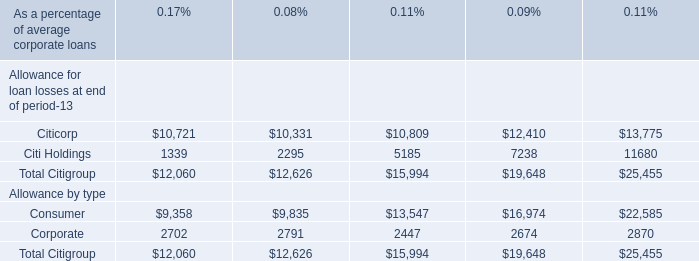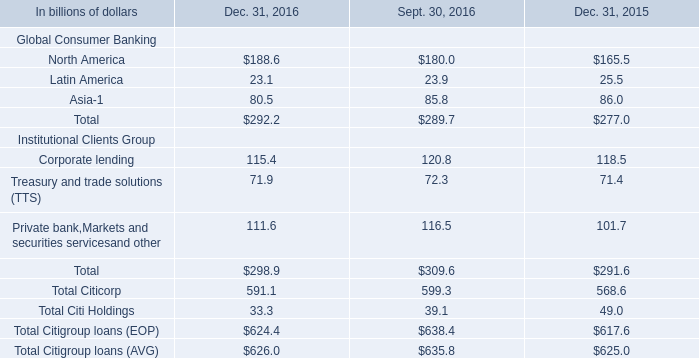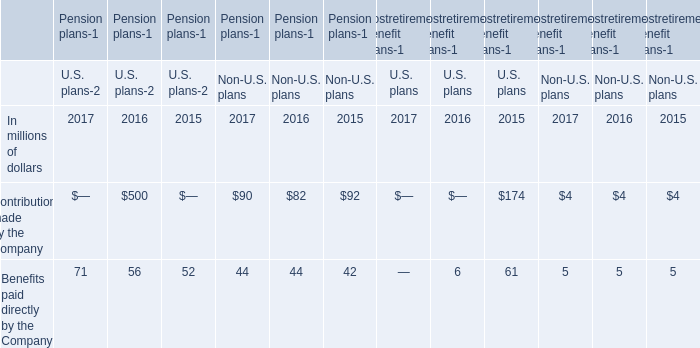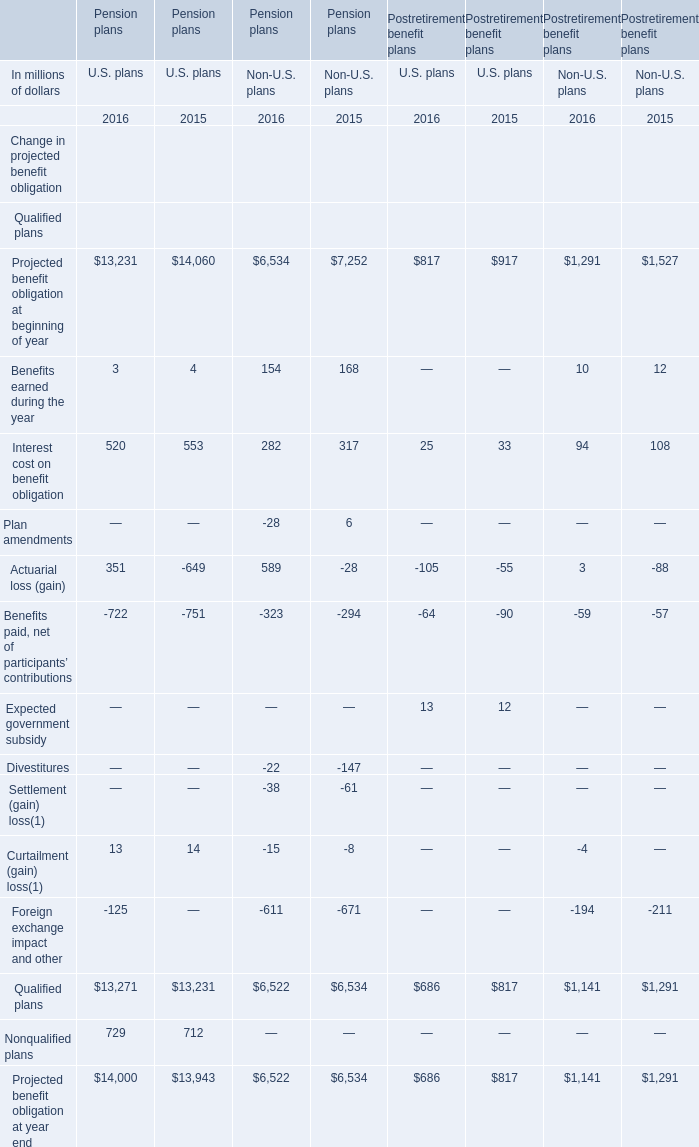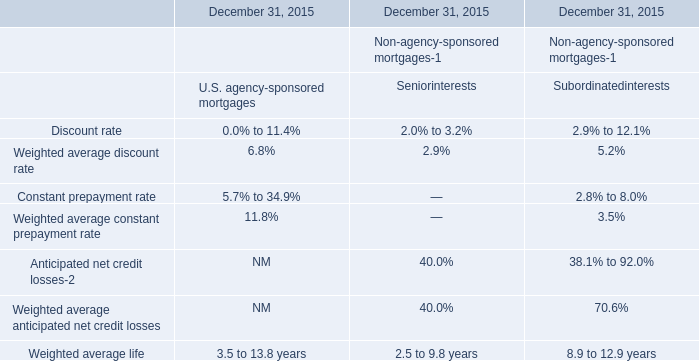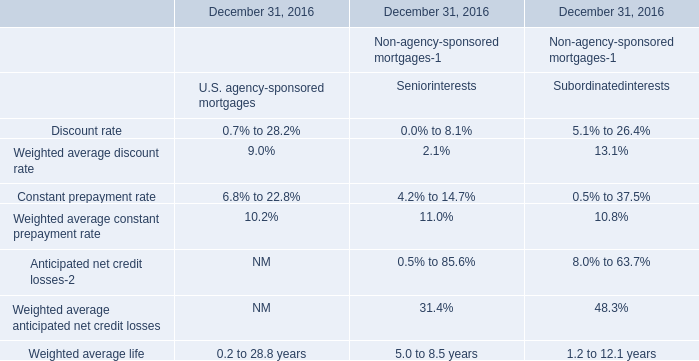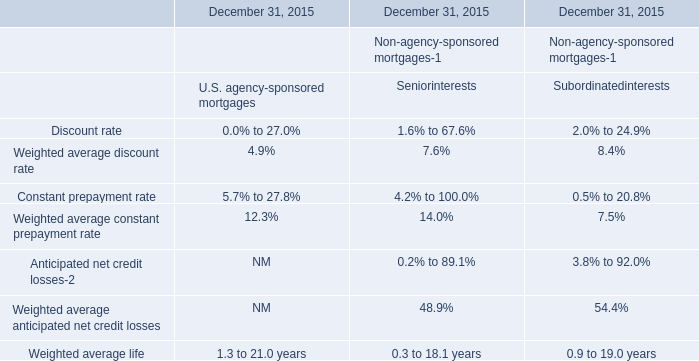What was the average value of the Interest cost on benefit obligation in the years where Pension plans U.S. plans Actuarial loss (gain) is positive? (in million) 
Computations: ((520 + 553) / 2)
Answer: 536.5. 